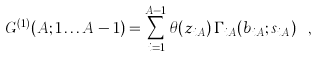Convert formula to latex. <formula><loc_0><loc_0><loc_500><loc_500>G ^ { ( 1 ) } ( A ; 1 \dots A - 1 ) = \sum _ { i = 1 } ^ { A - 1 } \theta ( z _ { i A } ) \, \Gamma _ { i A } ( { b } _ { i A } ; s _ { i A } ) \ ,</formula> 